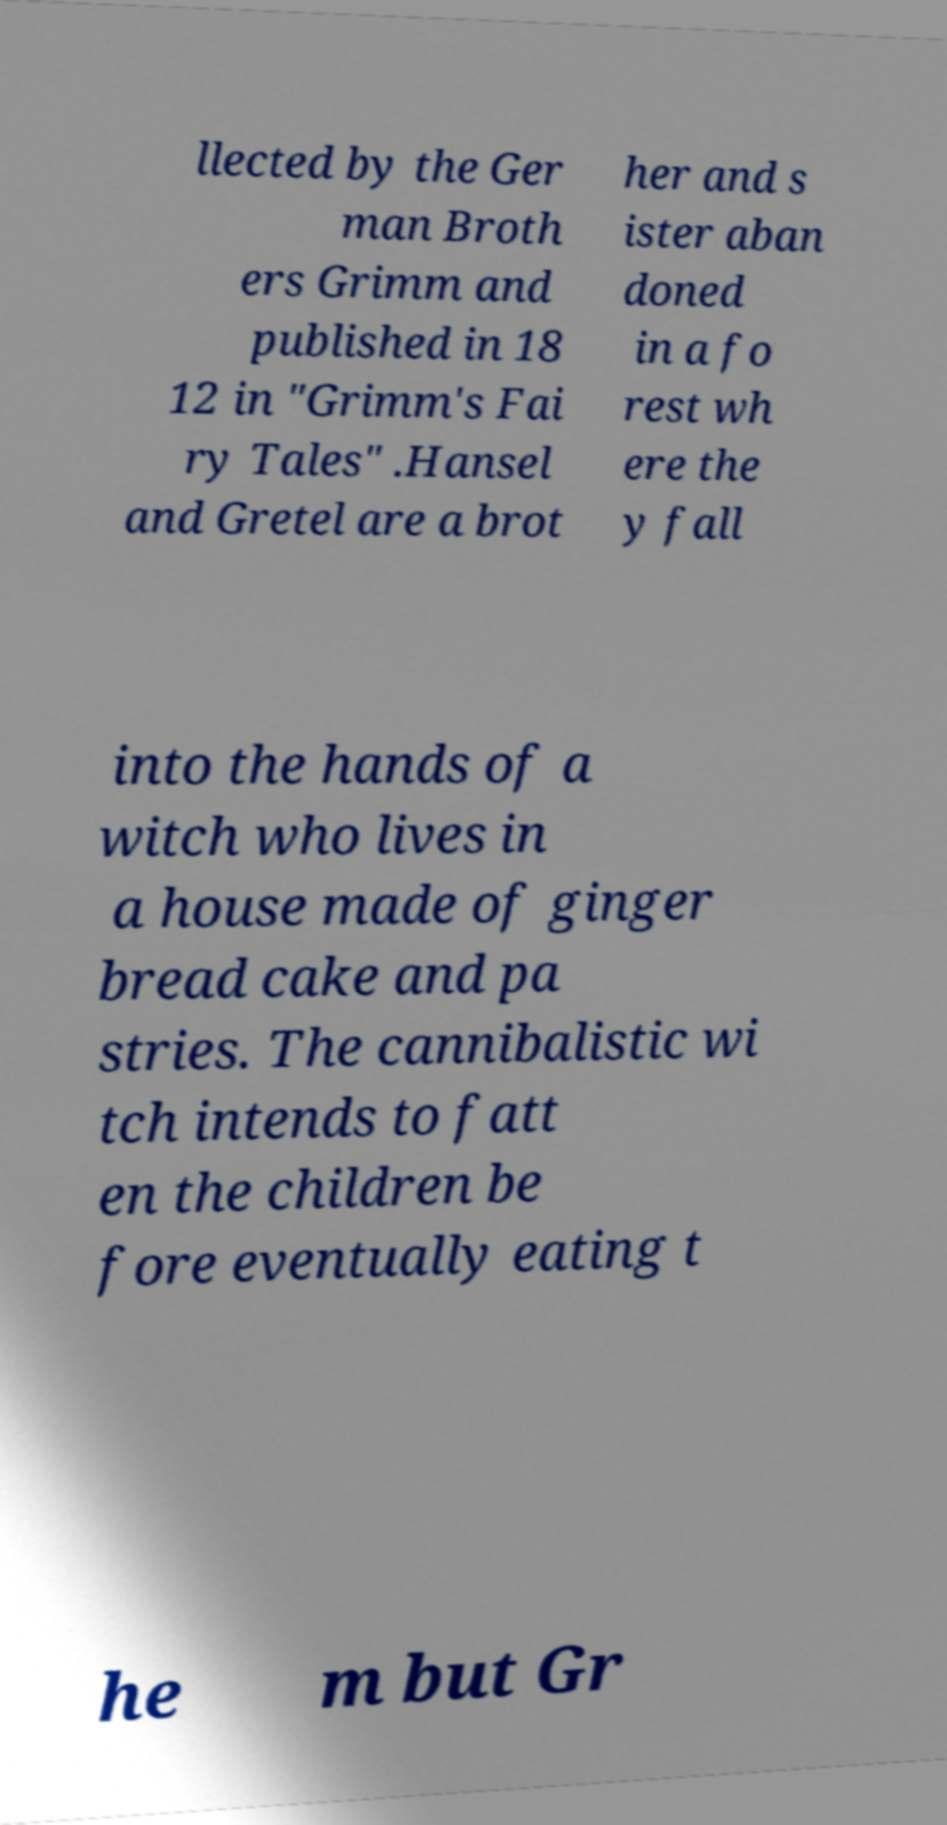Please read and relay the text visible in this image. What does it say? llected by the Ger man Broth ers Grimm and published in 18 12 in "Grimm's Fai ry Tales" .Hansel and Gretel are a brot her and s ister aban doned in a fo rest wh ere the y fall into the hands of a witch who lives in a house made of ginger bread cake and pa stries. The cannibalistic wi tch intends to fatt en the children be fore eventually eating t he m but Gr 